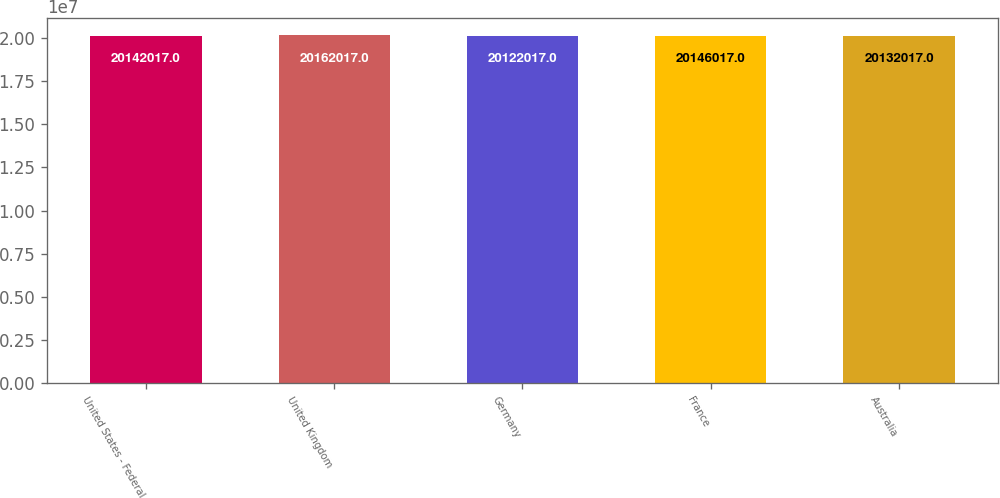<chart> <loc_0><loc_0><loc_500><loc_500><bar_chart><fcel>United States - Federal<fcel>United Kingdom<fcel>Germany<fcel>France<fcel>Australia<nl><fcel>2.0142e+07<fcel>2.0162e+07<fcel>2.0122e+07<fcel>2.0146e+07<fcel>2.0132e+07<nl></chart> 